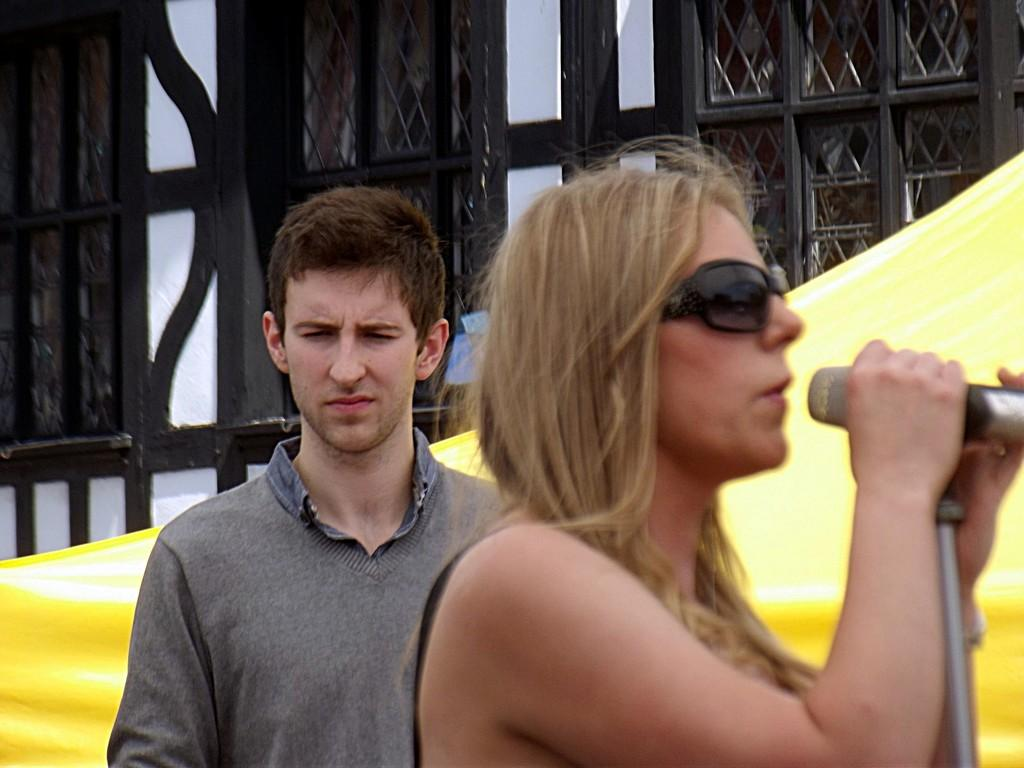How many people are present in the image? There are two people, a man and a woman, present in the image. What is the woman wearing in the image? The woman is wearing spectacles in the image. What is the woman holding in the image? The woman is holding a microphone in the image. What type of objects can be seen in the image that are made of metal? There are metal rods visible in the image. Can you see any fish swimming in the image? There are no fish present in the image. What type of donkey is carrying a tray in the image? There is no donkey or tray present in the image. 